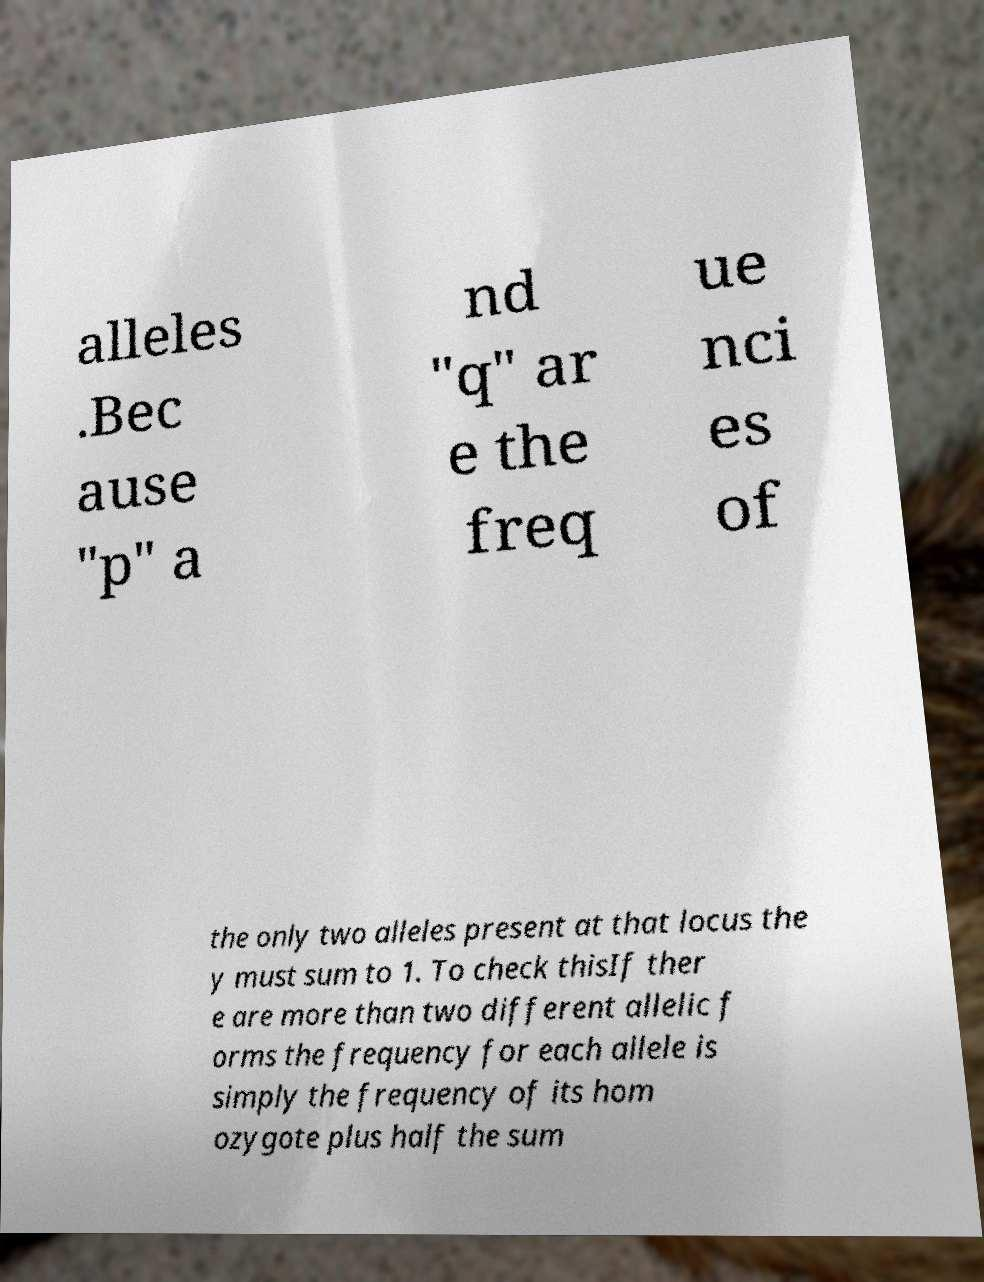There's text embedded in this image that I need extracted. Can you transcribe it verbatim? alleles .Bec ause "p" a nd "q" ar e the freq ue nci es of the only two alleles present at that locus the y must sum to 1. To check thisIf ther e are more than two different allelic f orms the frequency for each allele is simply the frequency of its hom ozygote plus half the sum 